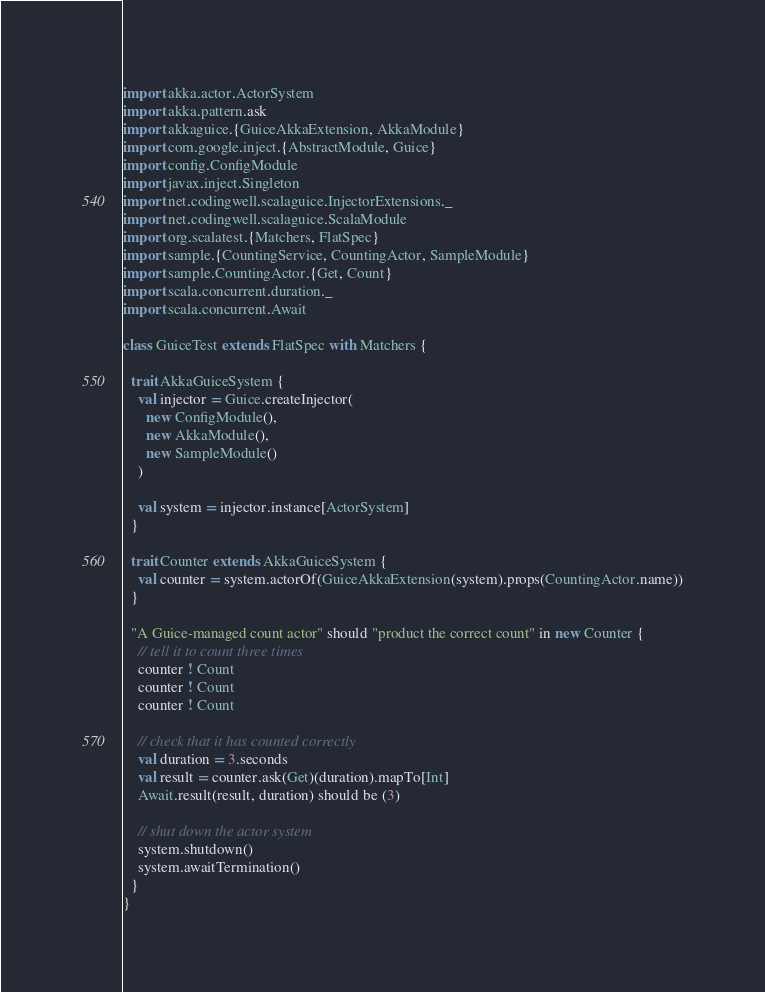Convert code to text. <code><loc_0><loc_0><loc_500><loc_500><_Scala_>import akka.actor.ActorSystem
import akka.pattern.ask
import akkaguice.{GuiceAkkaExtension, AkkaModule}
import com.google.inject.{AbstractModule, Guice}
import config.ConfigModule
import javax.inject.Singleton
import net.codingwell.scalaguice.InjectorExtensions._
import net.codingwell.scalaguice.ScalaModule
import org.scalatest.{Matchers, FlatSpec}
import sample.{CountingService, CountingActor, SampleModule}
import sample.CountingActor.{Get, Count}
import scala.concurrent.duration._
import scala.concurrent.Await

class GuiceTest extends FlatSpec with Matchers {

  trait AkkaGuiceSystem {
    val injector = Guice.createInjector(
      new ConfigModule(),
      new AkkaModule(),
      new SampleModule()
    )

    val system = injector.instance[ActorSystem]
  }

  trait Counter extends AkkaGuiceSystem {
    val counter = system.actorOf(GuiceAkkaExtension(system).props(CountingActor.name))
  }

  "A Guice-managed count actor" should "product the correct count" in new Counter {
    // tell it to count three times
    counter ! Count
    counter ! Count
    counter ! Count

    // check that it has counted correctly
    val duration = 3.seconds
    val result = counter.ask(Get)(duration).mapTo[Int]
    Await.result(result, duration) should be (3)

    // shut down the actor system
    system.shutdown()
    system.awaitTermination()
  }
}
</code> 